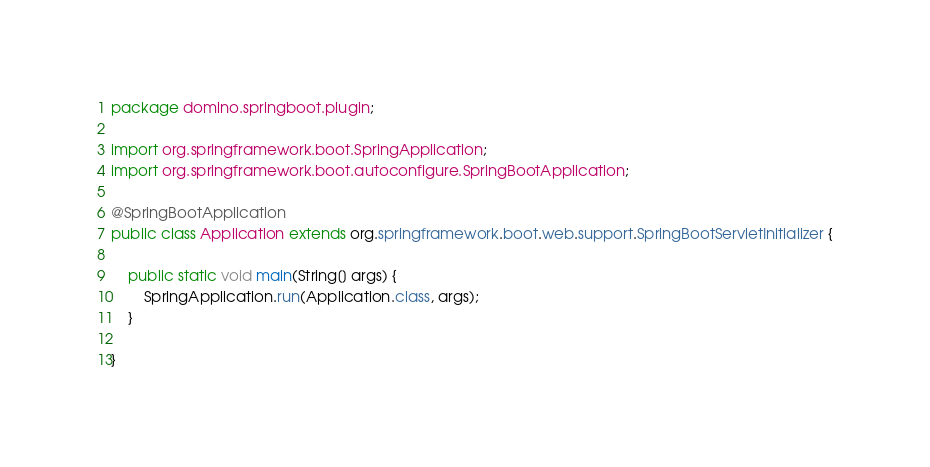Convert code to text. <code><loc_0><loc_0><loc_500><loc_500><_Java_>package domino.springboot.plugin;

import org.springframework.boot.SpringApplication;
import org.springframework.boot.autoconfigure.SpringBootApplication;

@SpringBootApplication
public class Application extends org.springframework.boot.web.support.SpringBootServletInitializer {

    public static void main(String[] args) {
        SpringApplication.run(Application.class, args);
    }

}</code> 